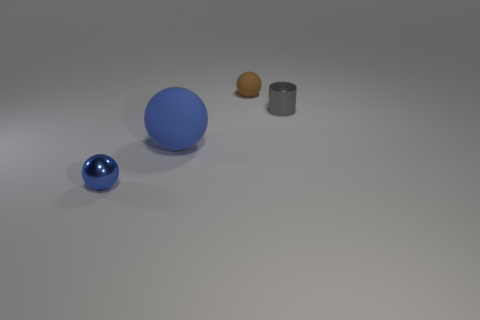How many other things are the same shape as the small blue object?
Your response must be concise. 2. There is a small ball that is behind the tiny metallic thing in front of the thing right of the brown rubber ball; what is it made of?
Provide a succinct answer. Rubber. How many other objects are the same size as the blue matte sphere?
Your answer should be compact. 0. What material is the other blue thing that is the same shape as the blue rubber object?
Offer a very short reply. Metal. What is the color of the shiny sphere?
Your answer should be compact. Blue. There is a matte thing behind the tiny metal object behind the blue shiny sphere; what is its color?
Your answer should be compact. Brown. Is the color of the big matte ball the same as the small sphere to the left of the tiny rubber ball?
Your response must be concise. Yes. There is a metallic cylinder behind the shiny object in front of the large matte ball; how many gray metal cylinders are on the right side of it?
Keep it short and to the point. 0. There is a small blue ball; are there any big spheres in front of it?
Give a very brief answer. No. Is there anything else that has the same color as the tiny cylinder?
Give a very brief answer. No. 